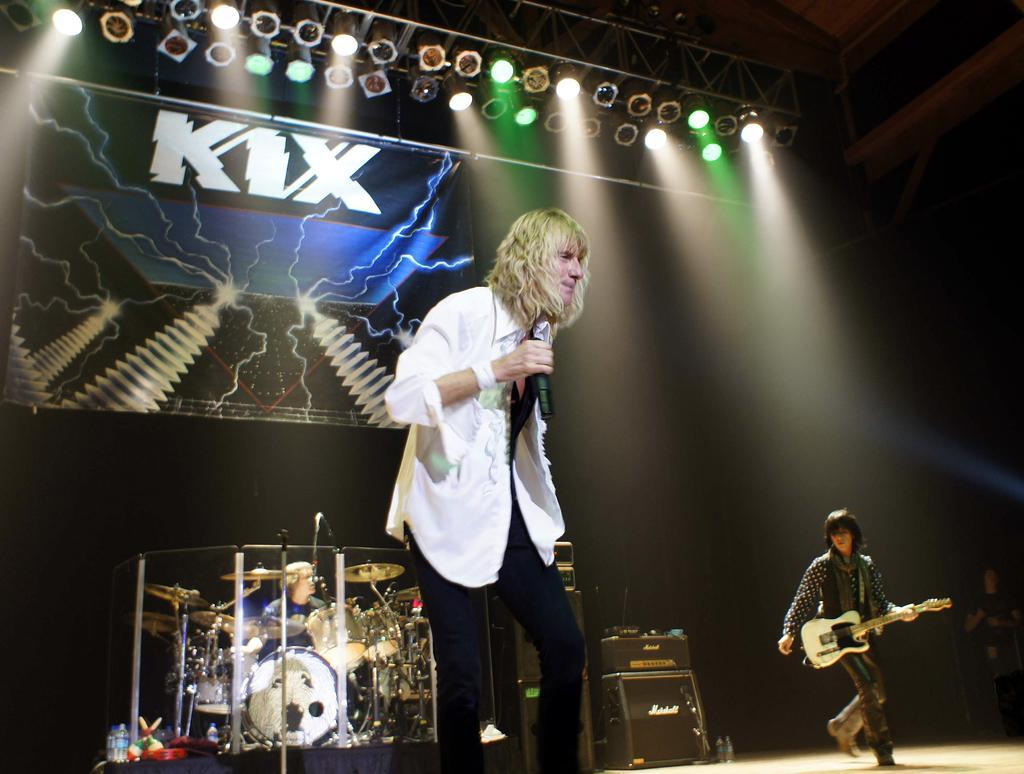Describe this image in one or two sentences. In this image, In the middle there is a man standing and holding a microphone which is in black color, In the right side there is a person standing and holding a music instrument which is in white color, In the background there are some music instruments. 